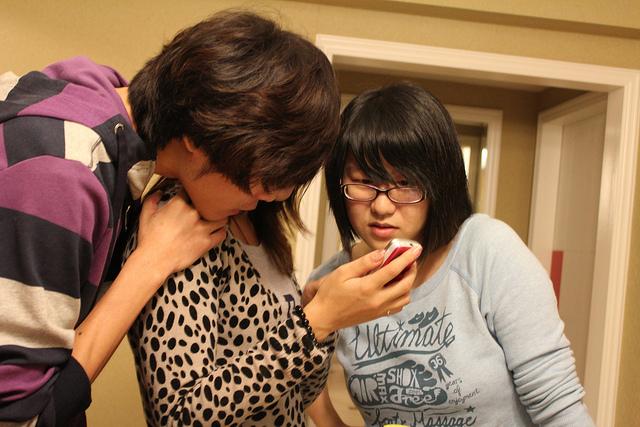What are they all looking at?
Short answer required. Phone. How many faces can be seen?
Be succinct. 2. Is the woman unhappy?
Quick response, please. No. 